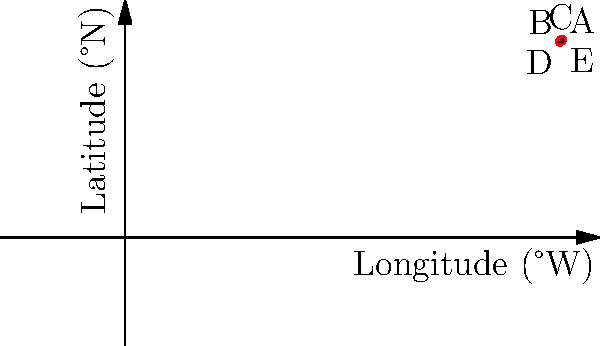An outbreak of a waterborne illness has been reported in a local community. Five cases (A, B, C, D, and E) have been identified and mapped using geographic coordinates. What is the area (in square degrees) of the smallest rectangular region that encompasses all reported cases? To find the area of the smallest rectangular region that encompasses all reported cases, we need to follow these steps:

1. Identify the extreme coordinates:
   - Westernmost point: D (82.2°W)
   - Easternmost point: E (82.6°W)
   - Southernmost point: D (37.0°N)
   - Northernmost point: E (37.4°N)

2. Calculate the width of the rectangle:
   $\text{Width} = 82.6°W - 82.2°W = 0.4°$

3. Calculate the height of the rectangle:
   $\text{Height} = 37.4°N - 37.0°N = 0.4°$

4. Calculate the area of the rectangle:
   $\text{Area} = \text{Width} \times \text{Height} = 0.4° \times 0.4° = 0.16$ square degrees

Therefore, the area of the smallest rectangular region that encompasses all reported cases is 0.16 square degrees.
Answer: 0.16 square degrees 